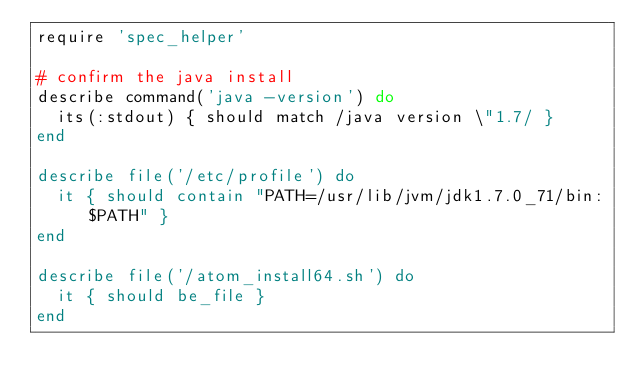<code> <loc_0><loc_0><loc_500><loc_500><_Ruby_>require 'spec_helper'

# confirm the java install
describe command('java -version') do
  its(:stdout) { should match /java version \"1.7/ }
end

describe file('/etc/profile') do
  it { should contain "PATH=/usr/lib/jvm/jdk1.7.0_71/bin:$PATH" }
end

describe file('/atom_install64.sh') do
  it { should be_file }
end</code> 